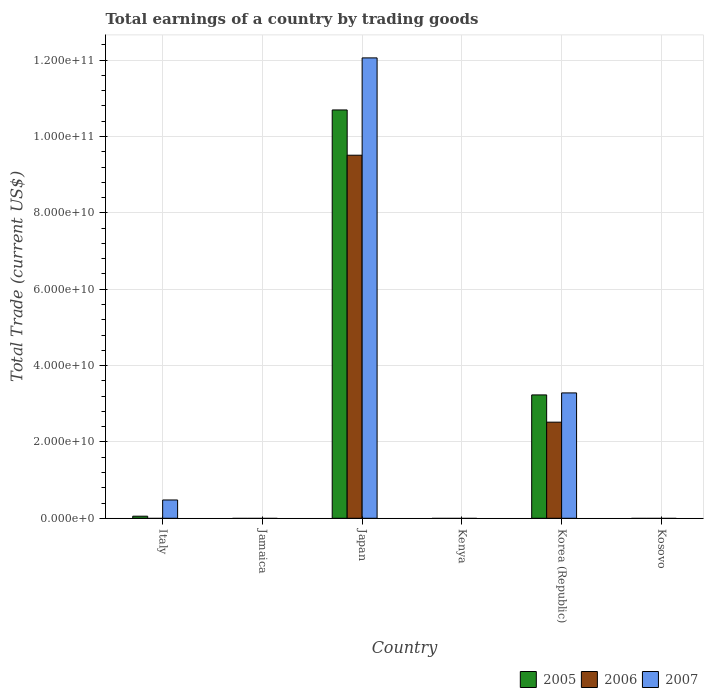Are the number of bars per tick equal to the number of legend labels?
Make the answer very short. No. What is the label of the 4th group of bars from the left?
Your answer should be compact. Kenya. What is the total earnings in 2006 in Kenya?
Your answer should be very brief. 0. Across all countries, what is the maximum total earnings in 2005?
Make the answer very short. 1.07e+11. Across all countries, what is the minimum total earnings in 2005?
Your answer should be very brief. 0. What is the total total earnings in 2007 in the graph?
Make the answer very short. 1.58e+11. What is the difference between the total earnings in 2007 in Kenya and the total earnings in 2005 in Kosovo?
Your answer should be compact. 0. What is the average total earnings in 2007 per country?
Give a very brief answer. 2.64e+1. What is the difference between the total earnings of/in 2006 and total earnings of/in 2007 in Korea (Republic)?
Your answer should be very brief. -7.66e+09. What is the ratio of the total earnings in 2007 in Italy to that in Korea (Republic)?
Your response must be concise. 0.15. What is the difference between the highest and the second highest total earnings in 2005?
Provide a short and direct response. 1.06e+11. What is the difference between the highest and the lowest total earnings in 2007?
Offer a very short reply. 1.21e+11. In how many countries, is the total earnings in 2005 greater than the average total earnings in 2005 taken over all countries?
Give a very brief answer. 2. Is it the case that in every country, the sum of the total earnings in 2006 and total earnings in 2007 is greater than the total earnings in 2005?
Your answer should be compact. No. How many bars are there?
Your answer should be very brief. 8. What is the difference between two consecutive major ticks on the Y-axis?
Provide a succinct answer. 2.00e+1. Are the values on the major ticks of Y-axis written in scientific E-notation?
Give a very brief answer. Yes. How many legend labels are there?
Your answer should be compact. 3. How are the legend labels stacked?
Your response must be concise. Horizontal. What is the title of the graph?
Provide a succinct answer. Total earnings of a country by trading goods. What is the label or title of the Y-axis?
Provide a succinct answer. Total Trade (current US$). What is the Total Trade (current US$) in 2005 in Italy?
Your answer should be compact. 5.43e+08. What is the Total Trade (current US$) in 2007 in Italy?
Ensure brevity in your answer.  4.79e+09. What is the Total Trade (current US$) in 2006 in Jamaica?
Offer a terse response. 0. What is the Total Trade (current US$) in 2005 in Japan?
Your response must be concise. 1.07e+11. What is the Total Trade (current US$) of 2006 in Japan?
Give a very brief answer. 9.51e+1. What is the Total Trade (current US$) in 2007 in Japan?
Your response must be concise. 1.21e+11. What is the Total Trade (current US$) in 2005 in Kenya?
Offer a terse response. 0. What is the Total Trade (current US$) in 2005 in Korea (Republic)?
Give a very brief answer. 3.23e+1. What is the Total Trade (current US$) of 2006 in Korea (Republic)?
Offer a terse response. 2.52e+1. What is the Total Trade (current US$) in 2007 in Korea (Republic)?
Offer a terse response. 3.28e+1. What is the Total Trade (current US$) in 2005 in Kosovo?
Keep it short and to the point. 0. What is the Total Trade (current US$) of 2006 in Kosovo?
Offer a very short reply. 0. Across all countries, what is the maximum Total Trade (current US$) in 2005?
Your answer should be compact. 1.07e+11. Across all countries, what is the maximum Total Trade (current US$) in 2006?
Your answer should be compact. 9.51e+1. Across all countries, what is the maximum Total Trade (current US$) in 2007?
Offer a very short reply. 1.21e+11. Across all countries, what is the minimum Total Trade (current US$) of 2007?
Provide a succinct answer. 0. What is the total Total Trade (current US$) of 2005 in the graph?
Ensure brevity in your answer.  1.40e+11. What is the total Total Trade (current US$) in 2006 in the graph?
Provide a short and direct response. 1.20e+11. What is the total Total Trade (current US$) in 2007 in the graph?
Give a very brief answer. 1.58e+11. What is the difference between the Total Trade (current US$) in 2005 in Italy and that in Japan?
Make the answer very short. -1.06e+11. What is the difference between the Total Trade (current US$) in 2007 in Italy and that in Japan?
Give a very brief answer. -1.16e+11. What is the difference between the Total Trade (current US$) of 2005 in Italy and that in Korea (Republic)?
Your answer should be compact. -3.18e+1. What is the difference between the Total Trade (current US$) in 2007 in Italy and that in Korea (Republic)?
Offer a terse response. -2.80e+1. What is the difference between the Total Trade (current US$) of 2005 in Japan and that in Korea (Republic)?
Your response must be concise. 7.47e+1. What is the difference between the Total Trade (current US$) in 2006 in Japan and that in Korea (Republic)?
Your response must be concise. 6.99e+1. What is the difference between the Total Trade (current US$) in 2007 in Japan and that in Korea (Republic)?
Your response must be concise. 8.78e+1. What is the difference between the Total Trade (current US$) of 2005 in Italy and the Total Trade (current US$) of 2006 in Japan?
Give a very brief answer. -9.46e+1. What is the difference between the Total Trade (current US$) in 2005 in Italy and the Total Trade (current US$) in 2007 in Japan?
Make the answer very short. -1.20e+11. What is the difference between the Total Trade (current US$) of 2005 in Italy and the Total Trade (current US$) of 2006 in Korea (Republic)?
Ensure brevity in your answer.  -2.46e+1. What is the difference between the Total Trade (current US$) in 2005 in Italy and the Total Trade (current US$) in 2007 in Korea (Republic)?
Offer a very short reply. -3.23e+1. What is the difference between the Total Trade (current US$) of 2005 in Japan and the Total Trade (current US$) of 2006 in Korea (Republic)?
Your answer should be very brief. 8.18e+1. What is the difference between the Total Trade (current US$) in 2005 in Japan and the Total Trade (current US$) in 2007 in Korea (Republic)?
Offer a terse response. 7.41e+1. What is the difference between the Total Trade (current US$) in 2006 in Japan and the Total Trade (current US$) in 2007 in Korea (Republic)?
Offer a terse response. 6.23e+1. What is the average Total Trade (current US$) in 2005 per country?
Your response must be concise. 2.33e+1. What is the average Total Trade (current US$) of 2006 per country?
Your answer should be very brief. 2.00e+1. What is the average Total Trade (current US$) in 2007 per country?
Your response must be concise. 2.64e+1. What is the difference between the Total Trade (current US$) of 2005 and Total Trade (current US$) of 2007 in Italy?
Keep it short and to the point. -4.25e+09. What is the difference between the Total Trade (current US$) of 2005 and Total Trade (current US$) of 2006 in Japan?
Your answer should be very brief. 1.19e+1. What is the difference between the Total Trade (current US$) in 2005 and Total Trade (current US$) in 2007 in Japan?
Ensure brevity in your answer.  -1.36e+1. What is the difference between the Total Trade (current US$) in 2006 and Total Trade (current US$) in 2007 in Japan?
Keep it short and to the point. -2.55e+1. What is the difference between the Total Trade (current US$) in 2005 and Total Trade (current US$) in 2006 in Korea (Republic)?
Your answer should be very brief. 7.14e+09. What is the difference between the Total Trade (current US$) in 2005 and Total Trade (current US$) in 2007 in Korea (Republic)?
Keep it short and to the point. -5.25e+08. What is the difference between the Total Trade (current US$) in 2006 and Total Trade (current US$) in 2007 in Korea (Republic)?
Give a very brief answer. -7.66e+09. What is the ratio of the Total Trade (current US$) of 2005 in Italy to that in Japan?
Provide a succinct answer. 0.01. What is the ratio of the Total Trade (current US$) in 2007 in Italy to that in Japan?
Make the answer very short. 0.04. What is the ratio of the Total Trade (current US$) in 2005 in Italy to that in Korea (Republic)?
Offer a very short reply. 0.02. What is the ratio of the Total Trade (current US$) of 2007 in Italy to that in Korea (Republic)?
Make the answer very short. 0.15. What is the ratio of the Total Trade (current US$) in 2005 in Japan to that in Korea (Republic)?
Your response must be concise. 3.31. What is the ratio of the Total Trade (current US$) in 2006 in Japan to that in Korea (Republic)?
Your response must be concise. 3.78. What is the ratio of the Total Trade (current US$) in 2007 in Japan to that in Korea (Republic)?
Ensure brevity in your answer.  3.67. What is the difference between the highest and the second highest Total Trade (current US$) in 2005?
Offer a terse response. 7.47e+1. What is the difference between the highest and the second highest Total Trade (current US$) of 2007?
Offer a very short reply. 8.78e+1. What is the difference between the highest and the lowest Total Trade (current US$) of 2005?
Offer a terse response. 1.07e+11. What is the difference between the highest and the lowest Total Trade (current US$) in 2006?
Ensure brevity in your answer.  9.51e+1. What is the difference between the highest and the lowest Total Trade (current US$) of 2007?
Ensure brevity in your answer.  1.21e+11. 